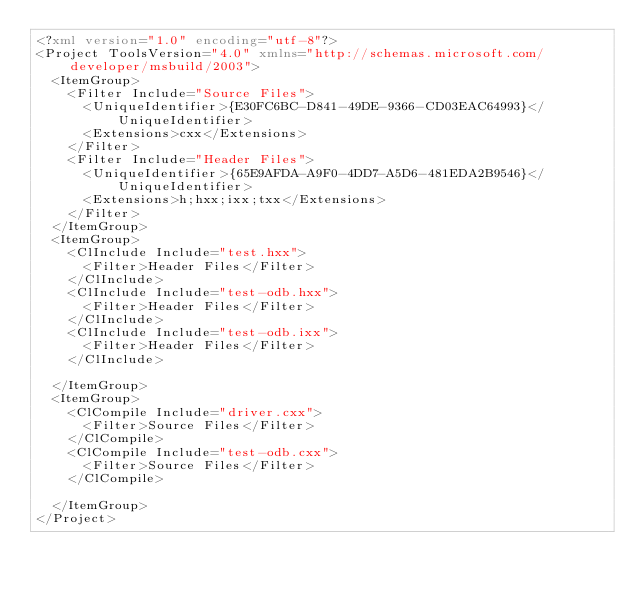<code> <loc_0><loc_0><loc_500><loc_500><_XML_><?xml version="1.0" encoding="utf-8"?>
<Project ToolsVersion="4.0" xmlns="http://schemas.microsoft.com/developer/msbuild/2003">
  <ItemGroup>
    <Filter Include="Source Files">
      <UniqueIdentifier>{E30FC6BC-D841-49DE-9366-CD03EAC64993}</UniqueIdentifier>
      <Extensions>cxx</Extensions>
    </Filter>
    <Filter Include="Header Files">
      <UniqueIdentifier>{65E9AFDA-A9F0-4DD7-A5D6-481EDA2B9546}</UniqueIdentifier>
      <Extensions>h;hxx;ixx;txx</Extensions>
    </Filter>
  </ItemGroup>
  <ItemGroup>
    <ClInclude Include="test.hxx">
      <Filter>Header Files</Filter>
    </ClInclude>
    <ClInclude Include="test-odb.hxx">
      <Filter>Header Files</Filter>
    </ClInclude>
    <ClInclude Include="test-odb.ixx">
      <Filter>Header Files</Filter>
    </ClInclude>

  </ItemGroup>
  <ItemGroup>
    <ClCompile Include="driver.cxx">
      <Filter>Source Files</Filter>
    </ClCompile>
    <ClCompile Include="test-odb.cxx">
      <Filter>Source Files</Filter>
    </ClCompile>

  </ItemGroup>
</Project>
</code> 